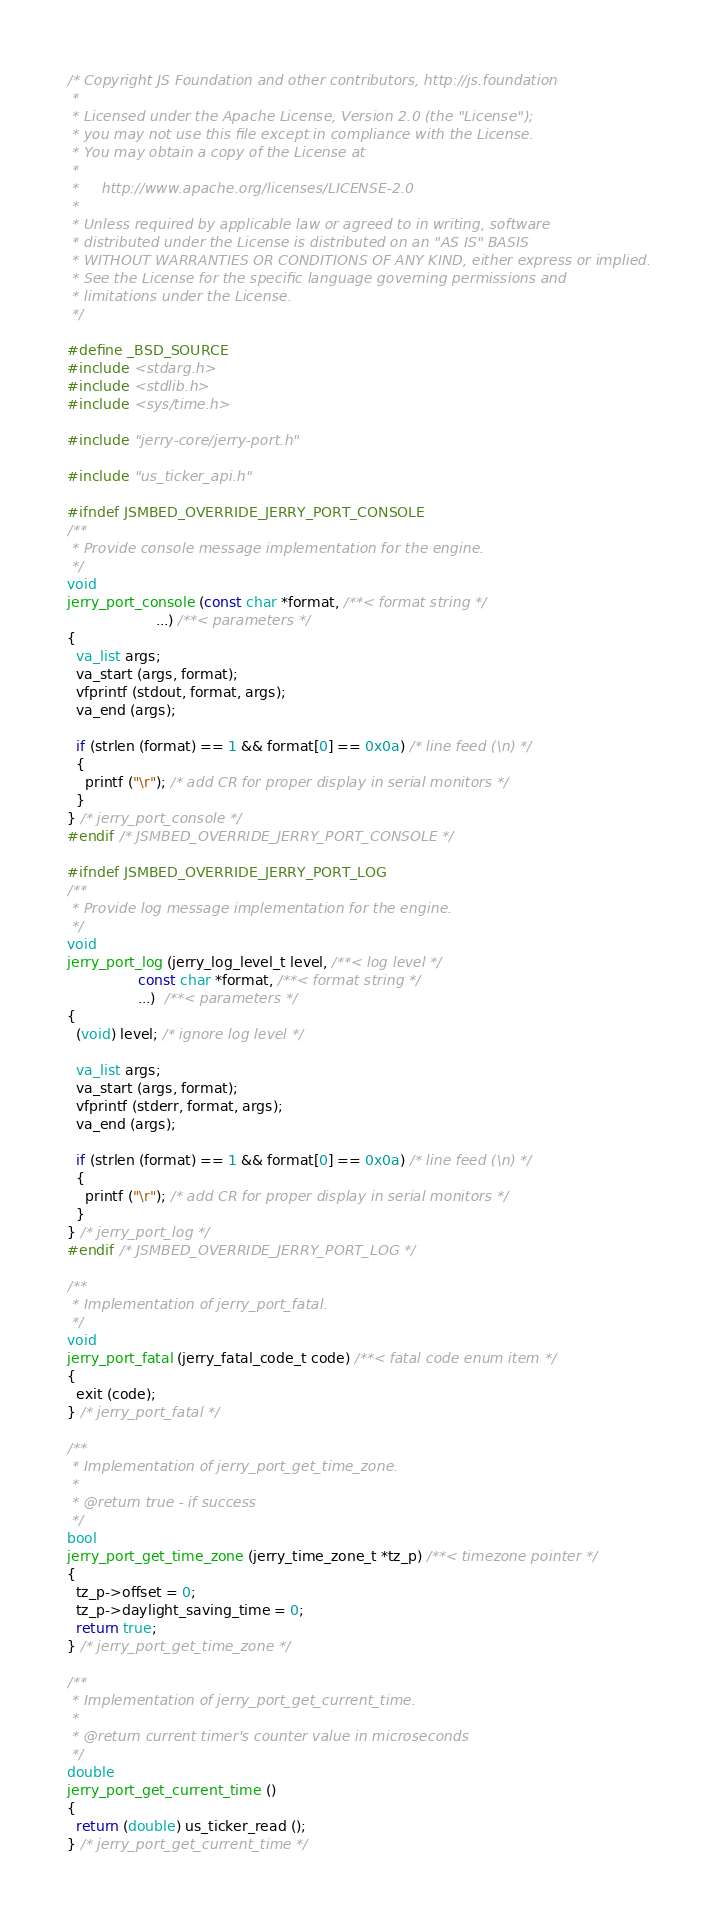Convert code to text. <code><loc_0><loc_0><loc_500><loc_500><_C_>/* Copyright JS Foundation and other contributors, http://js.foundation
 *
 * Licensed under the Apache License, Version 2.0 (the "License");
 * you may not use this file except in compliance with the License.
 * You may obtain a copy of the License at
 *
 *     http://www.apache.org/licenses/LICENSE-2.0
 *
 * Unless required by applicable law or agreed to in writing, software
 * distributed under the License is distributed on an "AS IS" BASIS
 * WITHOUT WARRANTIES OR CONDITIONS OF ANY KIND, either express or implied.
 * See the License for the specific language governing permissions and
 * limitations under the License.
 */

#define _BSD_SOURCE
#include <stdarg.h>
#include <stdlib.h>
#include <sys/time.h>

#include "jerry-core/jerry-port.h"

#include "us_ticker_api.h"

#ifndef JSMBED_OVERRIDE_JERRY_PORT_CONSOLE
/**
 * Provide console message implementation for the engine.
 */
void
jerry_port_console (const char *format, /**< format string */
                    ...) /**< parameters */
{
  va_list args;
  va_start (args, format);
  vfprintf (stdout, format, args);
  va_end (args);

  if (strlen (format) == 1 && format[0] == 0x0a) /* line feed (\n) */
  {
    printf ("\r"); /* add CR for proper display in serial monitors */
  }
} /* jerry_port_console */
#endif /* JSMBED_OVERRIDE_JERRY_PORT_CONSOLE */

#ifndef JSMBED_OVERRIDE_JERRY_PORT_LOG
/**
 * Provide log message implementation for the engine.
 */
void
jerry_port_log (jerry_log_level_t level, /**< log level */
                const char *format, /**< format string */
                ...)  /**< parameters */
{
  (void) level; /* ignore log level */

  va_list args;
  va_start (args, format);
  vfprintf (stderr, format, args);
  va_end (args);

  if (strlen (format) == 1 && format[0] == 0x0a) /* line feed (\n) */
  {
    printf ("\r"); /* add CR for proper display in serial monitors */
  }
} /* jerry_port_log */
#endif /* JSMBED_OVERRIDE_JERRY_PORT_LOG */

/**
 * Implementation of jerry_port_fatal.
 */
void
jerry_port_fatal (jerry_fatal_code_t code) /**< fatal code enum item */
{
  exit (code);
} /* jerry_port_fatal */

/**
 * Implementation of jerry_port_get_time_zone.
 *
 * @return true - if success
 */
bool
jerry_port_get_time_zone (jerry_time_zone_t *tz_p) /**< timezone pointer */
{
  tz_p->offset = 0;
  tz_p->daylight_saving_time = 0;
  return true;
} /* jerry_port_get_time_zone */

/**
 * Implementation of jerry_port_get_current_time.
 *
 * @return current timer's counter value in microseconds
 */
double
jerry_port_get_current_time ()
{
  return (double) us_ticker_read ();
} /* jerry_port_get_current_time */
</code> 